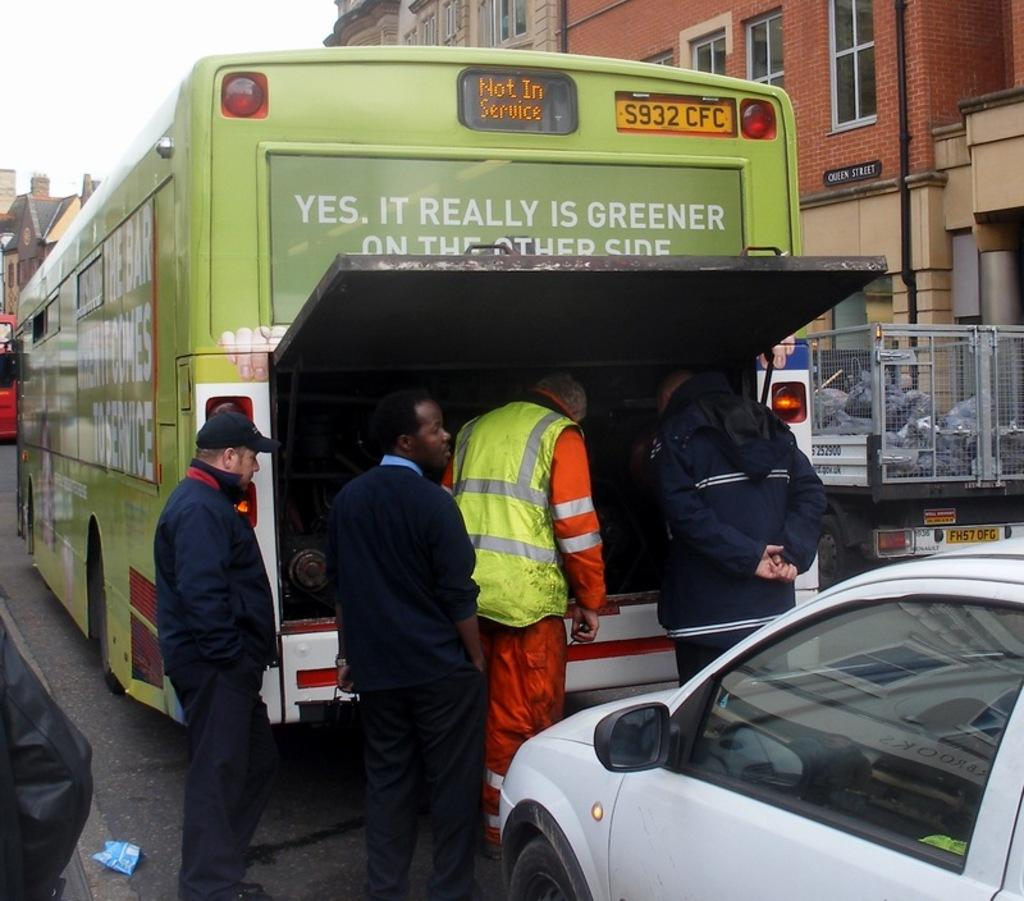<image>
Offer a succinct explanation of the picture presented. Four men are standing around a bus with license plate number S932 CFC and the bus is currently not in service. 